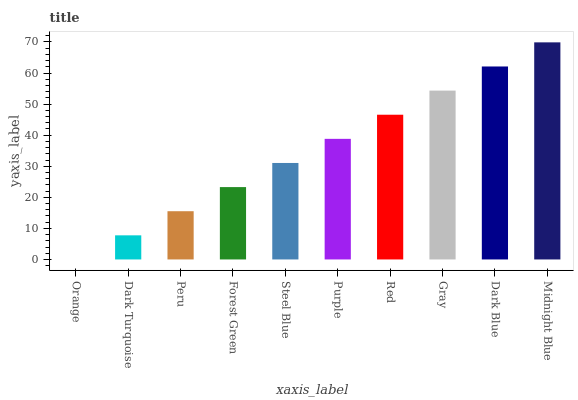Is Dark Turquoise the minimum?
Answer yes or no. No. Is Dark Turquoise the maximum?
Answer yes or no. No. Is Dark Turquoise greater than Orange?
Answer yes or no. Yes. Is Orange less than Dark Turquoise?
Answer yes or no. Yes. Is Orange greater than Dark Turquoise?
Answer yes or no. No. Is Dark Turquoise less than Orange?
Answer yes or no. No. Is Purple the high median?
Answer yes or no. Yes. Is Steel Blue the low median?
Answer yes or no. Yes. Is Dark Blue the high median?
Answer yes or no. No. Is Purple the low median?
Answer yes or no. No. 